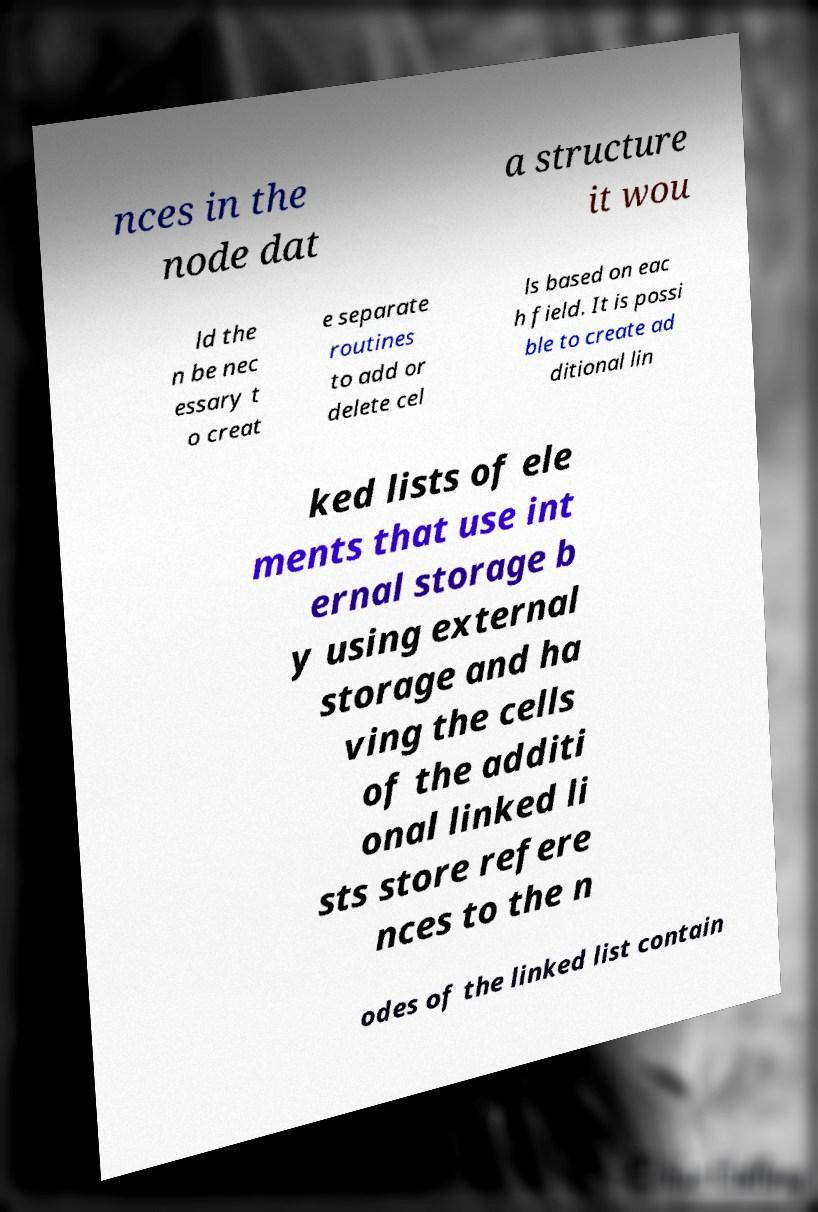What messages or text are displayed in this image? I need them in a readable, typed format. nces in the node dat a structure it wou ld the n be nec essary t o creat e separate routines to add or delete cel ls based on eac h field. It is possi ble to create ad ditional lin ked lists of ele ments that use int ernal storage b y using external storage and ha ving the cells of the additi onal linked li sts store refere nces to the n odes of the linked list contain 